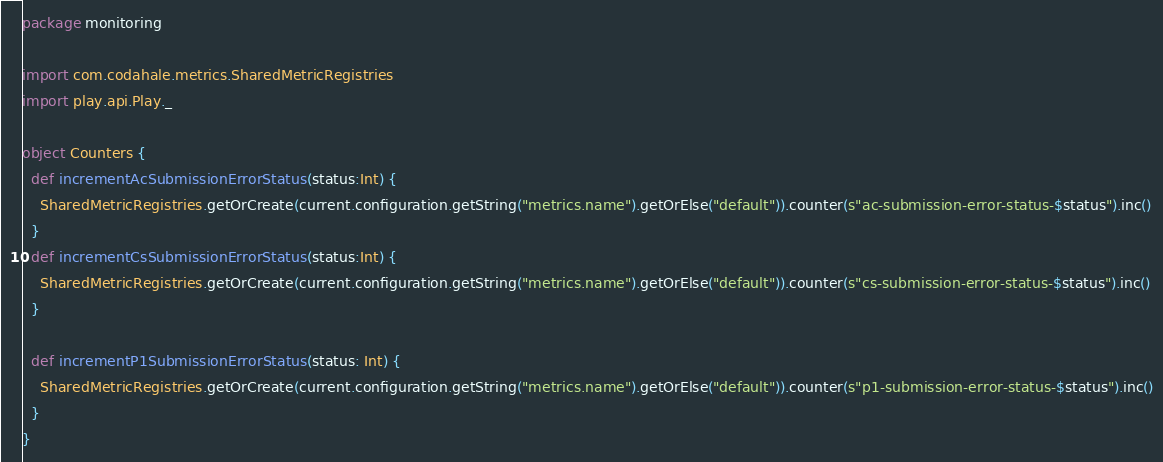<code> <loc_0><loc_0><loc_500><loc_500><_Scala_>package monitoring

import com.codahale.metrics.SharedMetricRegistries
import play.api.Play._

object Counters {
  def incrementAcSubmissionErrorStatus(status:Int) {
    SharedMetricRegistries.getOrCreate(current.configuration.getString("metrics.name").getOrElse("default")).counter(s"ac-submission-error-status-$status").inc()
  }
  def incrementCsSubmissionErrorStatus(status:Int) {
    SharedMetricRegistries.getOrCreate(current.configuration.getString("metrics.name").getOrElse("default")).counter(s"cs-submission-error-status-$status").inc()
  }

  def incrementP1SubmissionErrorStatus(status: Int) {
    SharedMetricRegistries.getOrCreate(current.configuration.getString("metrics.name").getOrElse("default")).counter(s"p1-submission-error-status-$status").inc()
  }
}
</code> 